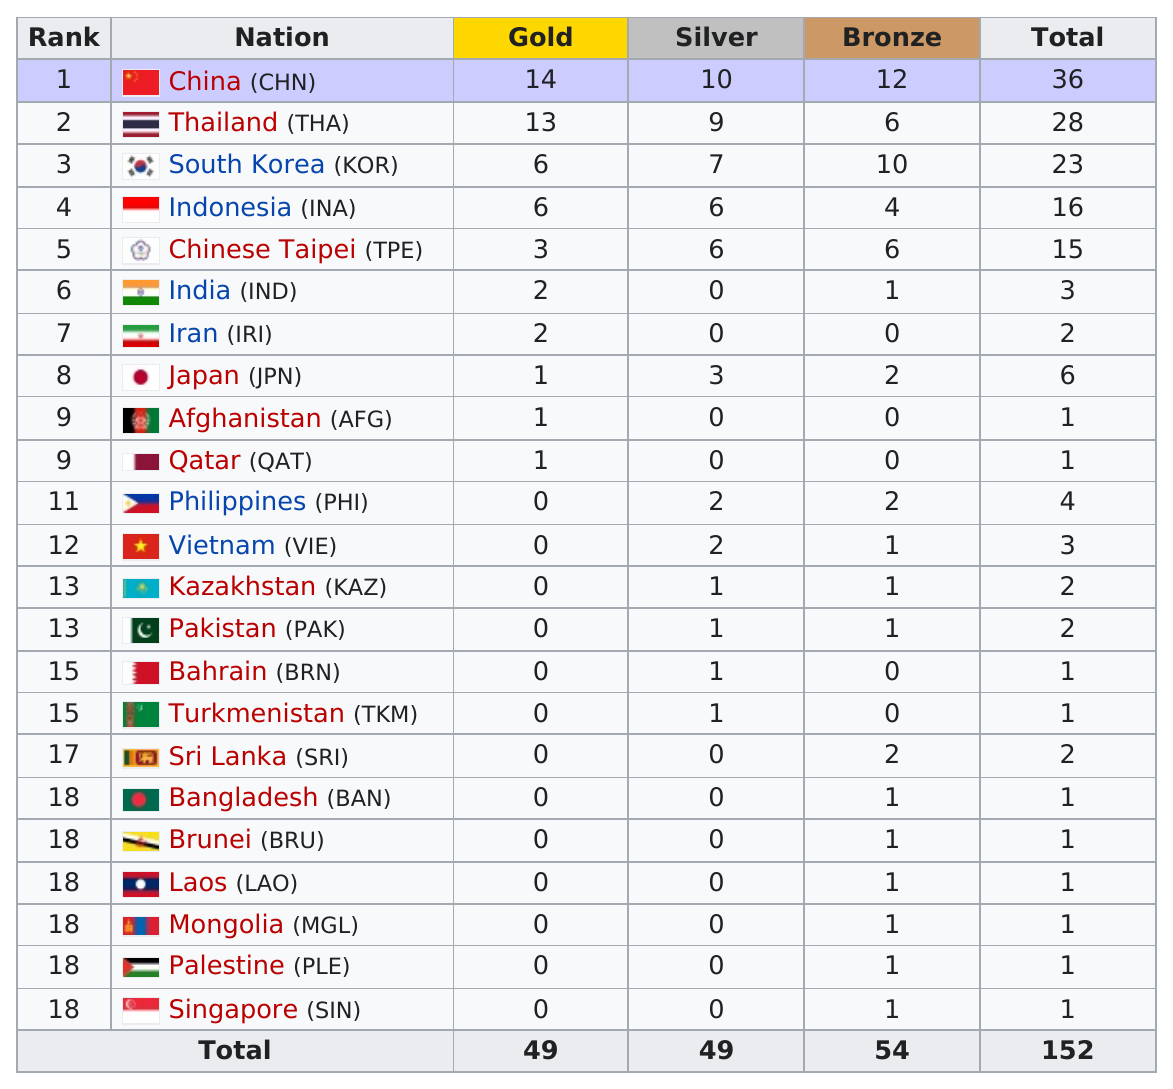Specify some key components in this picture. The nation that finished first in total medals earned was China. The total number of nations that participated in the beach games of 2012 was 23. China has won the most bronze medals. The Philippines or Kazakhstan had a higher number of total medals. India earned more medals than Pakistan in the competition. 